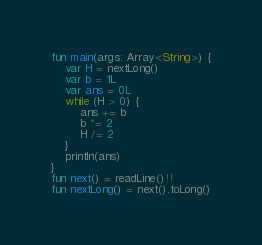Convert code to text. <code><loc_0><loc_0><loc_500><loc_500><_Kotlin_>fun main(args: Array<String>) {
    var H = nextLong()
    var b = 1L
    var ans = 0L
    while (H > 0) {
        ans += b
        b *= 2
        H /= 2
    }
    println(ans)
}
fun next() = readLine()!!
fun nextLong() = next().toLong()
</code> 